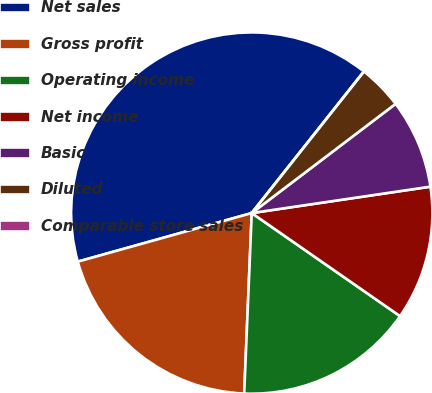<chart> <loc_0><loc_0><loc_500><loc_500><pie_chart><fcel>Net sales<fcel>Gross profit<fcel>Operating income<fcel>Net income<fcel>Basic<fcel>Diluted<fcel>Comparable store sales<nl><fcel>40.0%<fcel>20.0%<fcel>16.0%<fcel>12.0%<fcel>8.0%<fcel>4.0%<fcel>0.0%<nl></chart> 